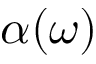Convert formula to latex. <formula><loc_0><loc_0><loc_500><loc_500>\alpha ( \omega )</formula> 